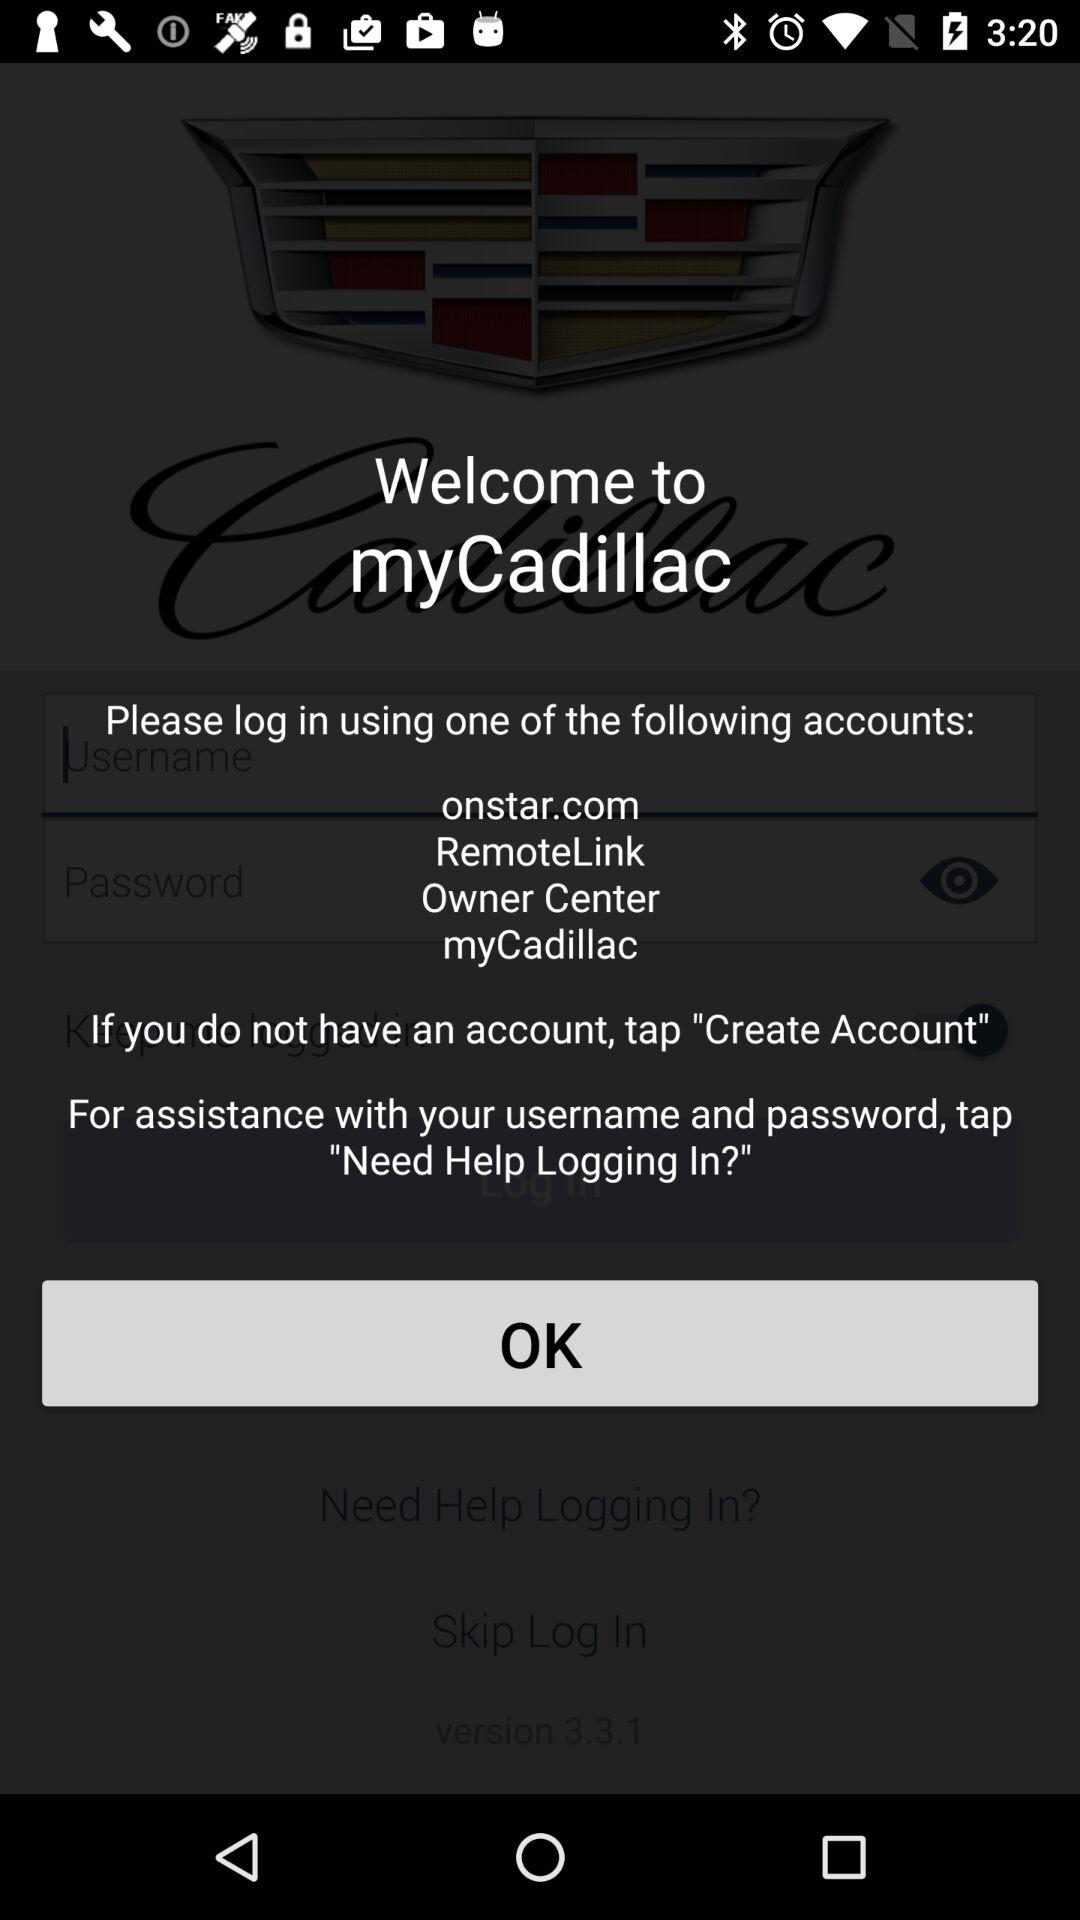What is the name of the application? The application name is "myCadillac". 